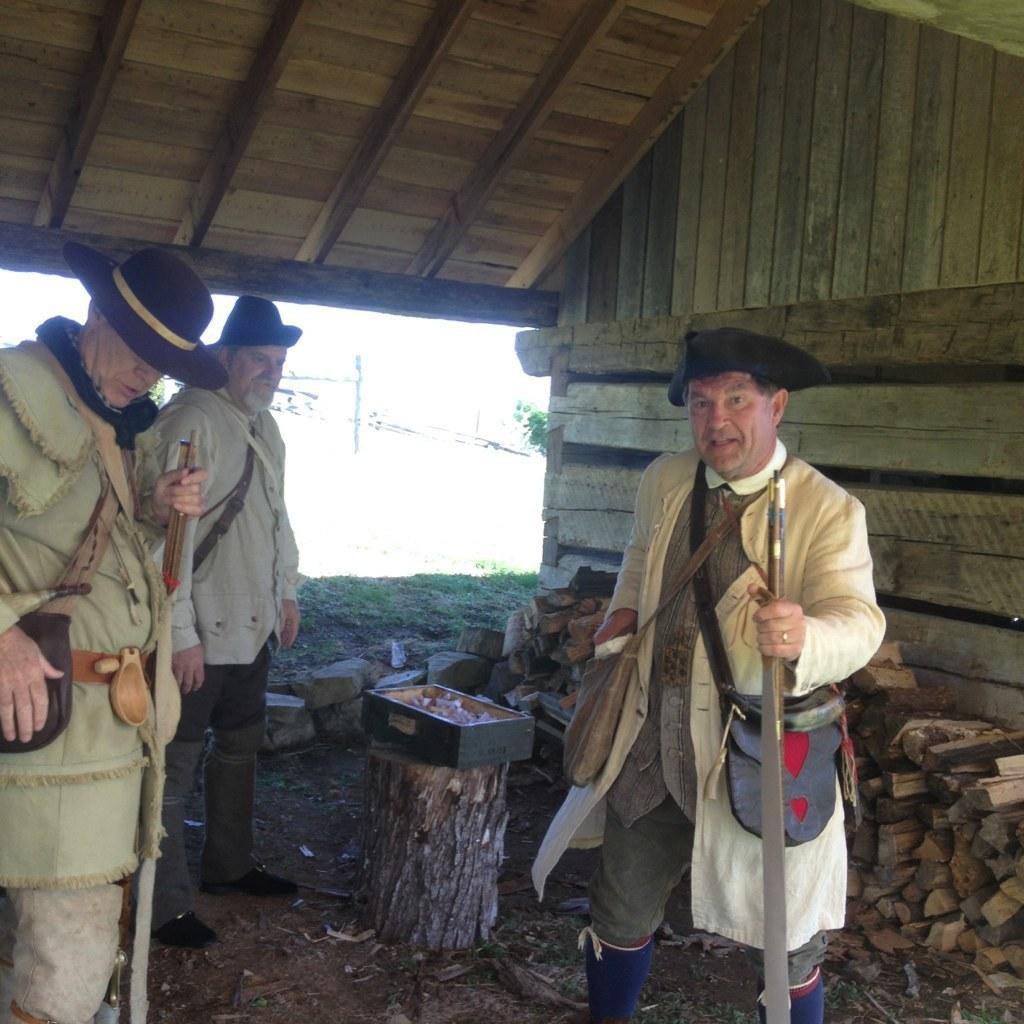How would you summarize this image in a sentence or two? In this picture we can see three men wore caps, carrying bags, standing on the ground, two men are holding sticks with their hands and at the back of them we can see wooden logs, stones, box, shed, grass and some objects. 